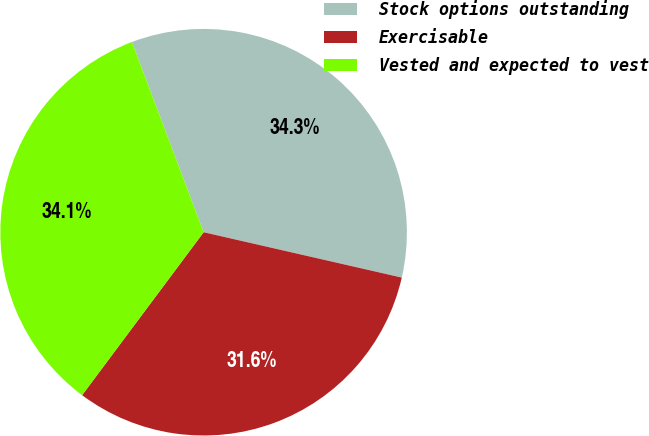Convert chart to OTSL. <chart><loc_0><loc_0><loc_500><loc_500><pie_chart><fcel>Stock options outstanding<fcel>Exercisable<fcel>Vested and expected to vest<nl><fcel>34.32%<fcel>31.62%<fcel>34.07%<nl></chart> 